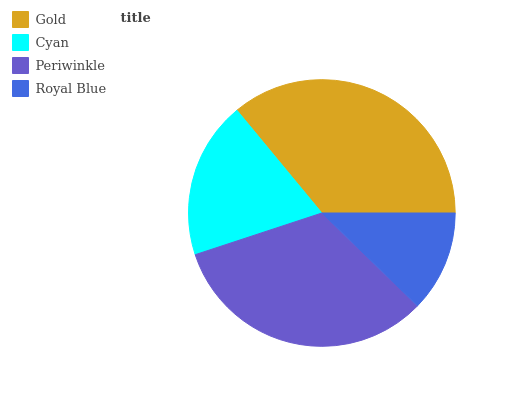Is Royal Blue the minimum?
Answer yes or no. Yes. Is Gold the maximum?
Answer yes or no. Yes. Is Cyan the minimum?
Answer yes or no. No. Is Cyan the maximum?
Answer yes or no. No. Is Gold greater than Cyan?
Answer yes or no. Yes. Is Cyan less than Gold?
Answer yes or no. Yes. Is Cyan greater than Gold?
Answer yes or no. No. Is Gold less than Cyan?
Answer yes or no. No. Is Periwinkle the high median?
Answer yes or no. Yes. Is Cyan the low median?
Answer yes or no. Yes. Is Cyan the high median?
Answer yes or no. No. Is Periwinkle the low median?
Answer yes or no. No. 